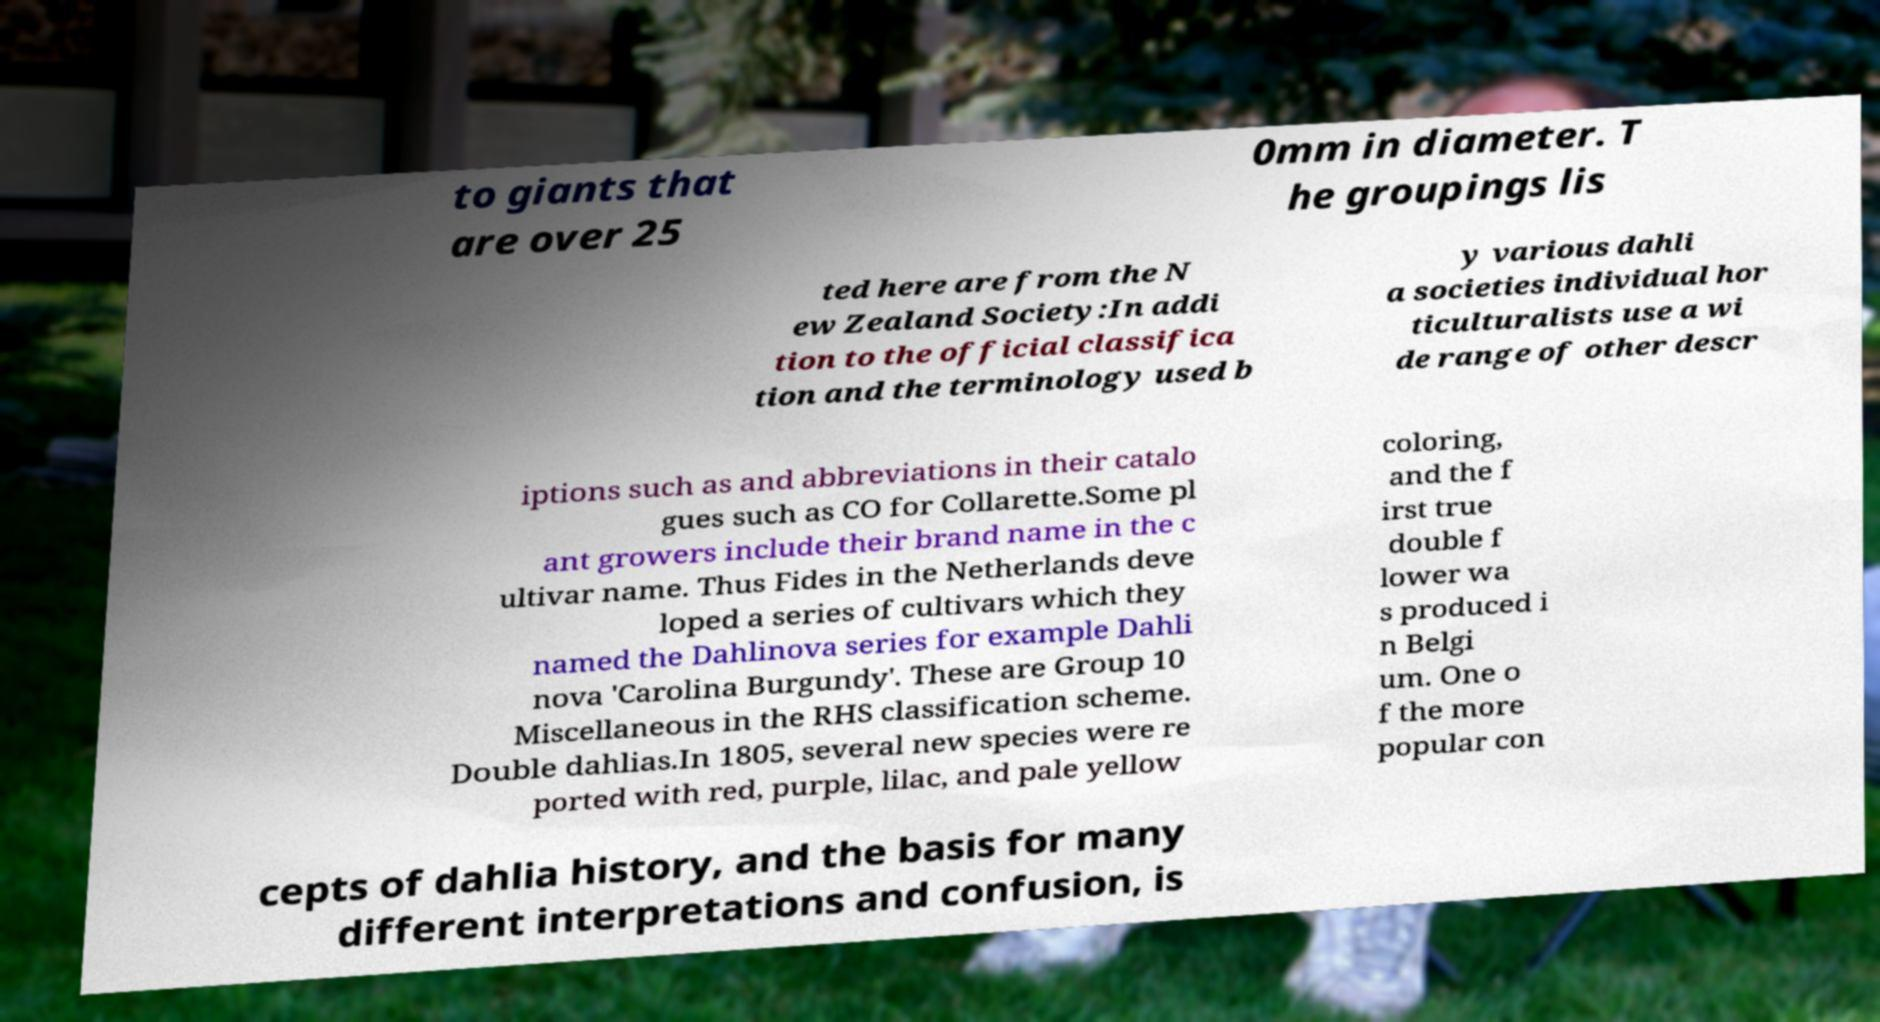Please read and relay the text visible in this image. What does it say? to giants that are over 25 0mm in diameter. T he groupings lis ted here are from the N ew Zealand Society:In addi tion to the official classifica tion and the terminology used b y various dahli a societies individual hor ticulturalists use a wi de range of other descr iptions such as and abbreviations in their catalo gues such as CO for Collarette.Some pl ant growers include their brand name in the c ultivar name. Thus Fides in the Netherlands deve loped a series of cultivars which they named the Dahlinova series for example Dahli nova 'Carolina Burgundy'. These are Group 10 Miscellaneous in the RHS classification scheme. Double dahlias.In 1805, several new species were re ported with red, purple, lilac, and pale yellow coloring, and the f irst true double f lower wa s produced i n Belgi um. One o f the more popular con cepts of dahlia history, and the basis for many different interpretations and confusion, is 